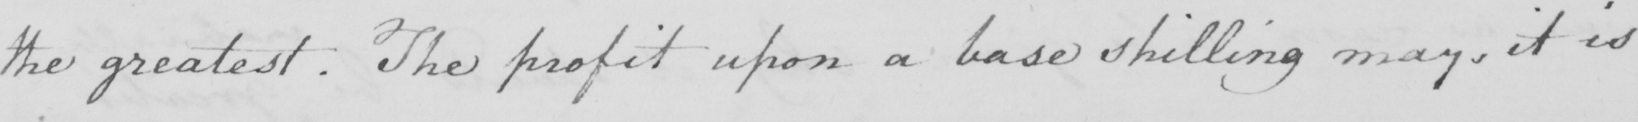Can you tell me what this handwritten text says? the greatest. The profit upon a base shilling may, it is 